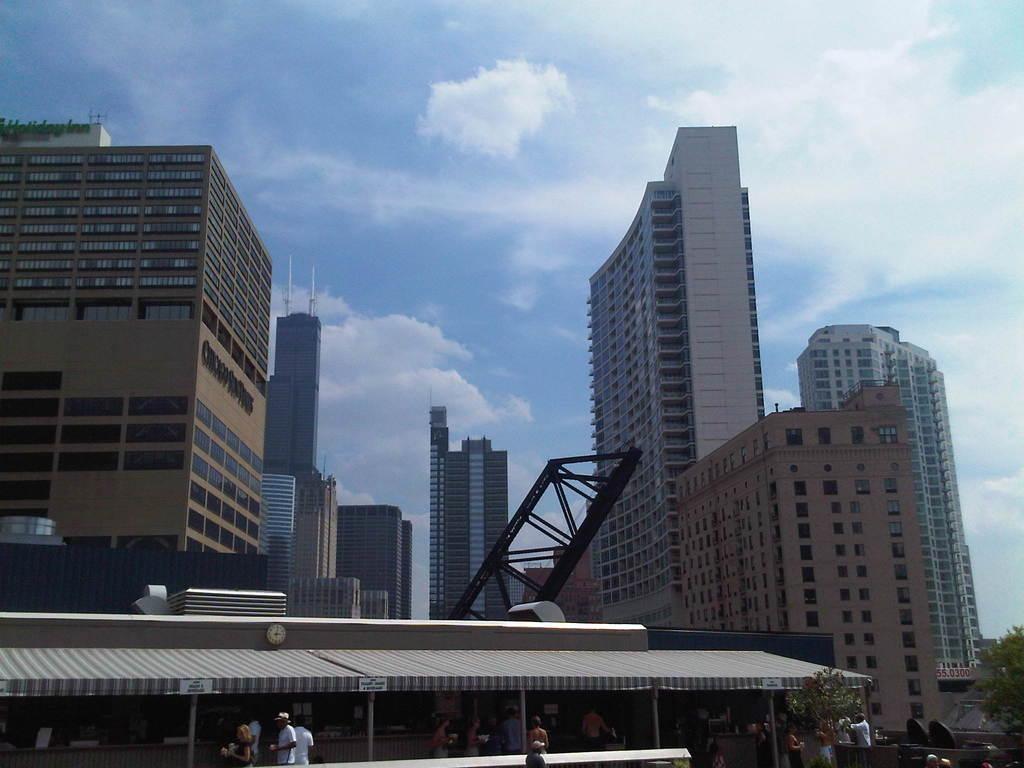Describe this image in one or two sentences. In this picture I can see there are few people walking here at left side and there is a building here and there is a clock. There are few trees on to right and there are few buildings in the backdrop and it has few windows and the sky is clear. 